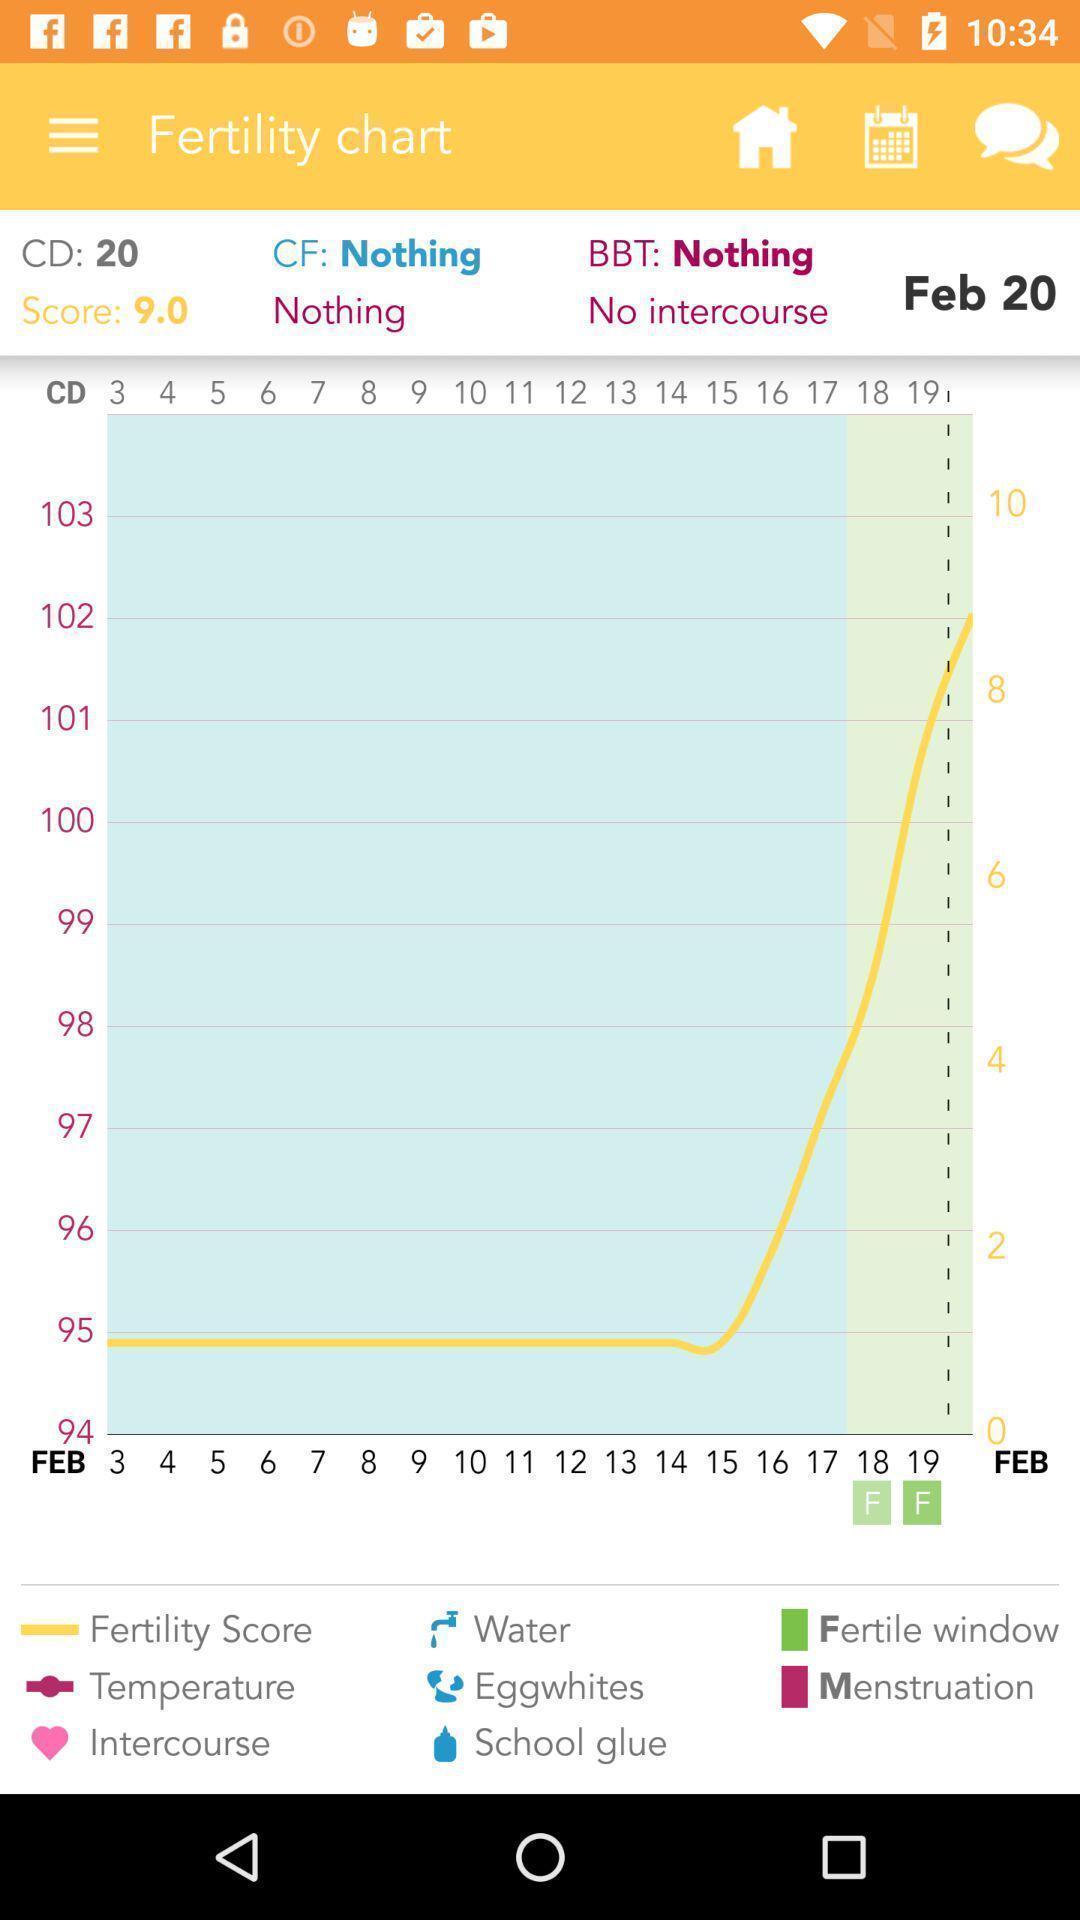Explain what's happening in this screen capture. Page showing a fertility chart. 